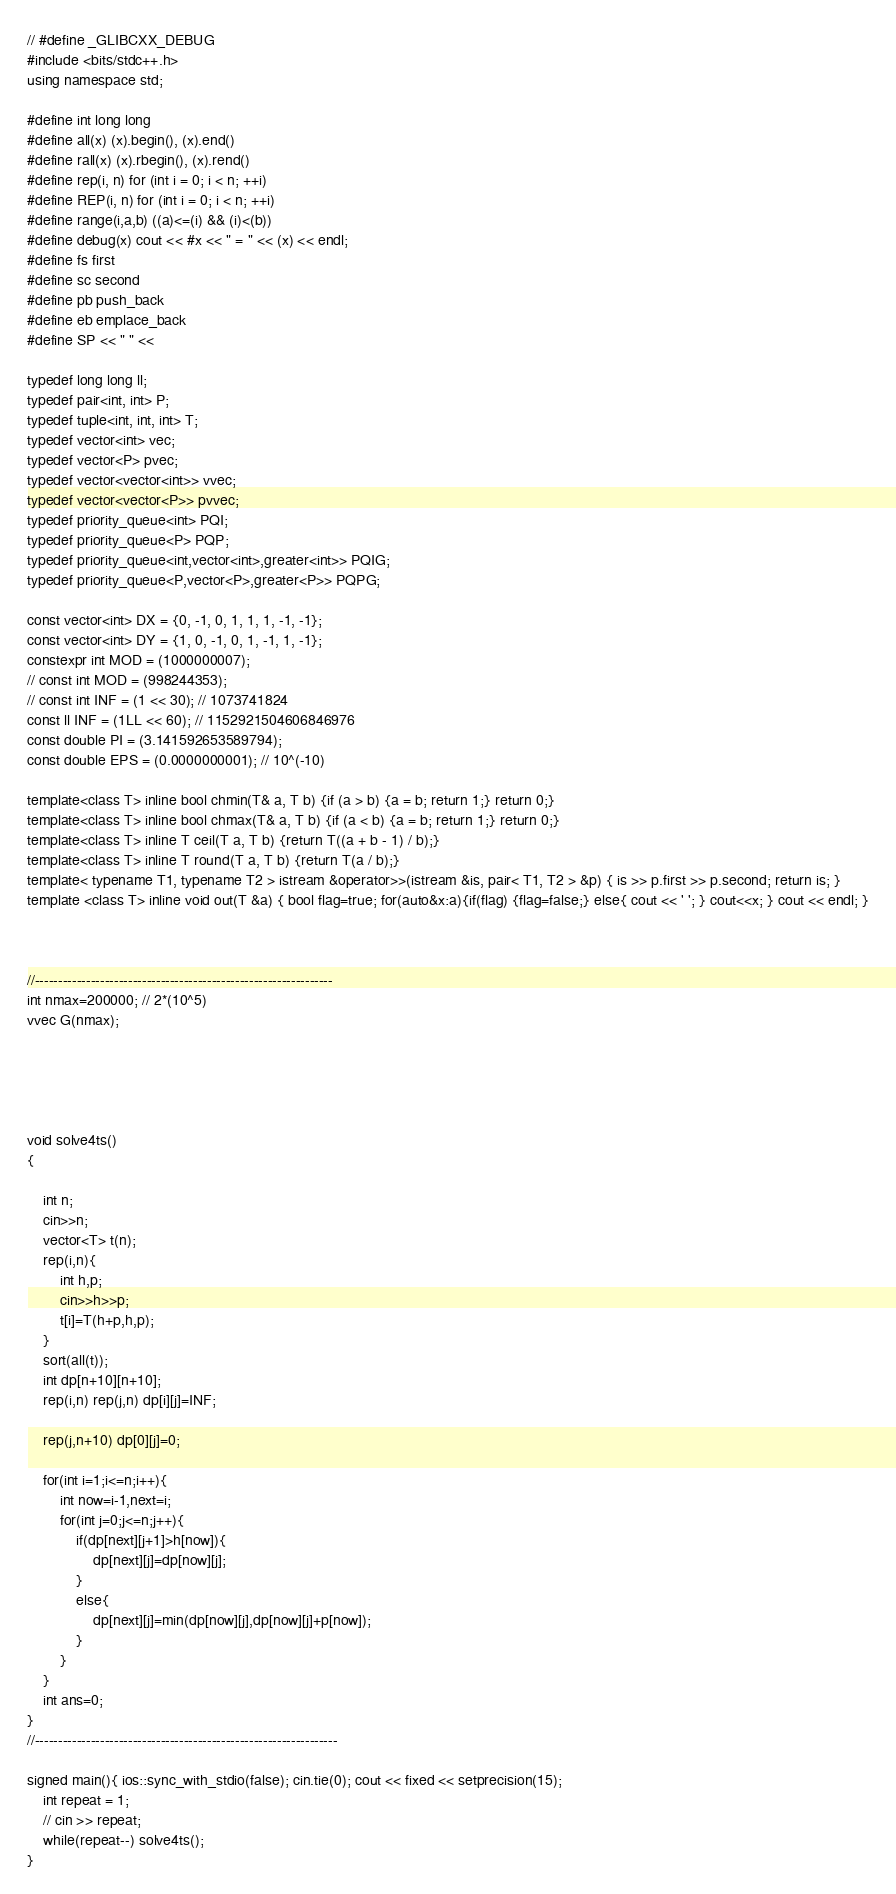Convert code to text. <code><loc_0><loc_0><loc_500><loc_500><_C++_>// #define _GLIBCXX_DEBUG
#include <bits/stdc++.h>
using namespace std;

#define int long long
#define all(x) (x).begin(), (x).end()
#define rall(x) (x).rbegin(), (x).rend()
#define rep(i, n) for (int i = 0; i < n; ++i)
#define REP(i, n) for (int i = 0; i < n; ++i)
#define range(i,a,b) ((a)<=(i) && (i)<(b))
#define debug(x) cout << #x << " = " << (x) << endl;
#define fs first
#define sc second
#define pb push_back
#define eb emplace_back
#define SP << " " <<

typedef long long ll;
typedef pair<int, int> P;
typedef tuple<int, int, int> T;
typedef vector<int> vec;
typedef vector<P> pvec;
typedef vector<vector<int>> vvec;
typedef vector<vector<P>> pvvec;
typedef priority_queue<int> PQI;
typedef priority_queue<P> PQP;
typedef priority_queue<int,vector<int>,greater<int>> PQIG;
typedef priority_queue<P,vector<P>,greater<P>> PQPG;

const vector<int> DX = {0, -1, 0, 1, 1, 1, -1, -1};
const vector<int> DY = {1, 0, -1, 0, 1, -1, 1, -1};
constexpr int MOD = (1000000007);
// const int MOD = (998244353);
// const int INF = (1 << 30); // 1073741824
const ll INF = (1LL << 60); // 1152921504606846976
const double PI = (3.141592653589794);
const double EPS = (0.0000000001); // 10^(-10)

template<class T> inline bool chmin(T& a, T b) {if (a > b) {a = b; return 1;} return 0;}
template<class T> inline bool chmax(T& a, T b) {if (a < b) {a = b; return 1;} return 0;}
template<class T> inline T ceil(T a, T b) {return T((a + b - 1) / b);}
template<class T> inline T round(T a, T b) {return T(a / b);}
template< typename T1, typename T2 > istream &operator>>(istream &is, pair< T1, T2 > &p) { is >> p.first >> p.second; return is; }
template <class T> inline void out(T &a) { bool flag=true; for(auto&x:a){if(flag) {flag=false;} else{ cout << ' '; } cout<<x; } cout << endl; }



//----------------------------------------------------------------
int nmax=200000; // 2*(10^5)
vvec G(nmax);





void solve4ts()
{
    
    int n;
    cin>>n;
    vector<T> t(n);
    rep(i,n){
        int h,p;
        cin>>h>>p;
        t[i]=T(h+p,h,p);
    }
    sort(all(t));
    int dp[n+10][n+10];
    rep(i,n) rep(j,n) dp[i][j]=INF;
    
    rep(j,n+10) dp[0][j]=0;

    for(int i=1;i<=n;i++){
        int now=i-1,next=i;
        for(int j=0;j<=n;j++){
            if(dp[next][j+1]>h[now]){
                dp[next][j]=dp[now][j];
            }
            else{
                dp[next][j]=min(dp[now][j],dp[now][j]+p[now]);
            }
        }
    }
    int ans=0;
}
//-----------------------------------------------------------------

signed main(){ ios::sync_with_stdio(false); cin.tie(0); cout << fixed << setprecision(15);
    int repeat = 1;
    // cin >> repeat;
    while(repeat--) solve4ts();
}</code> 